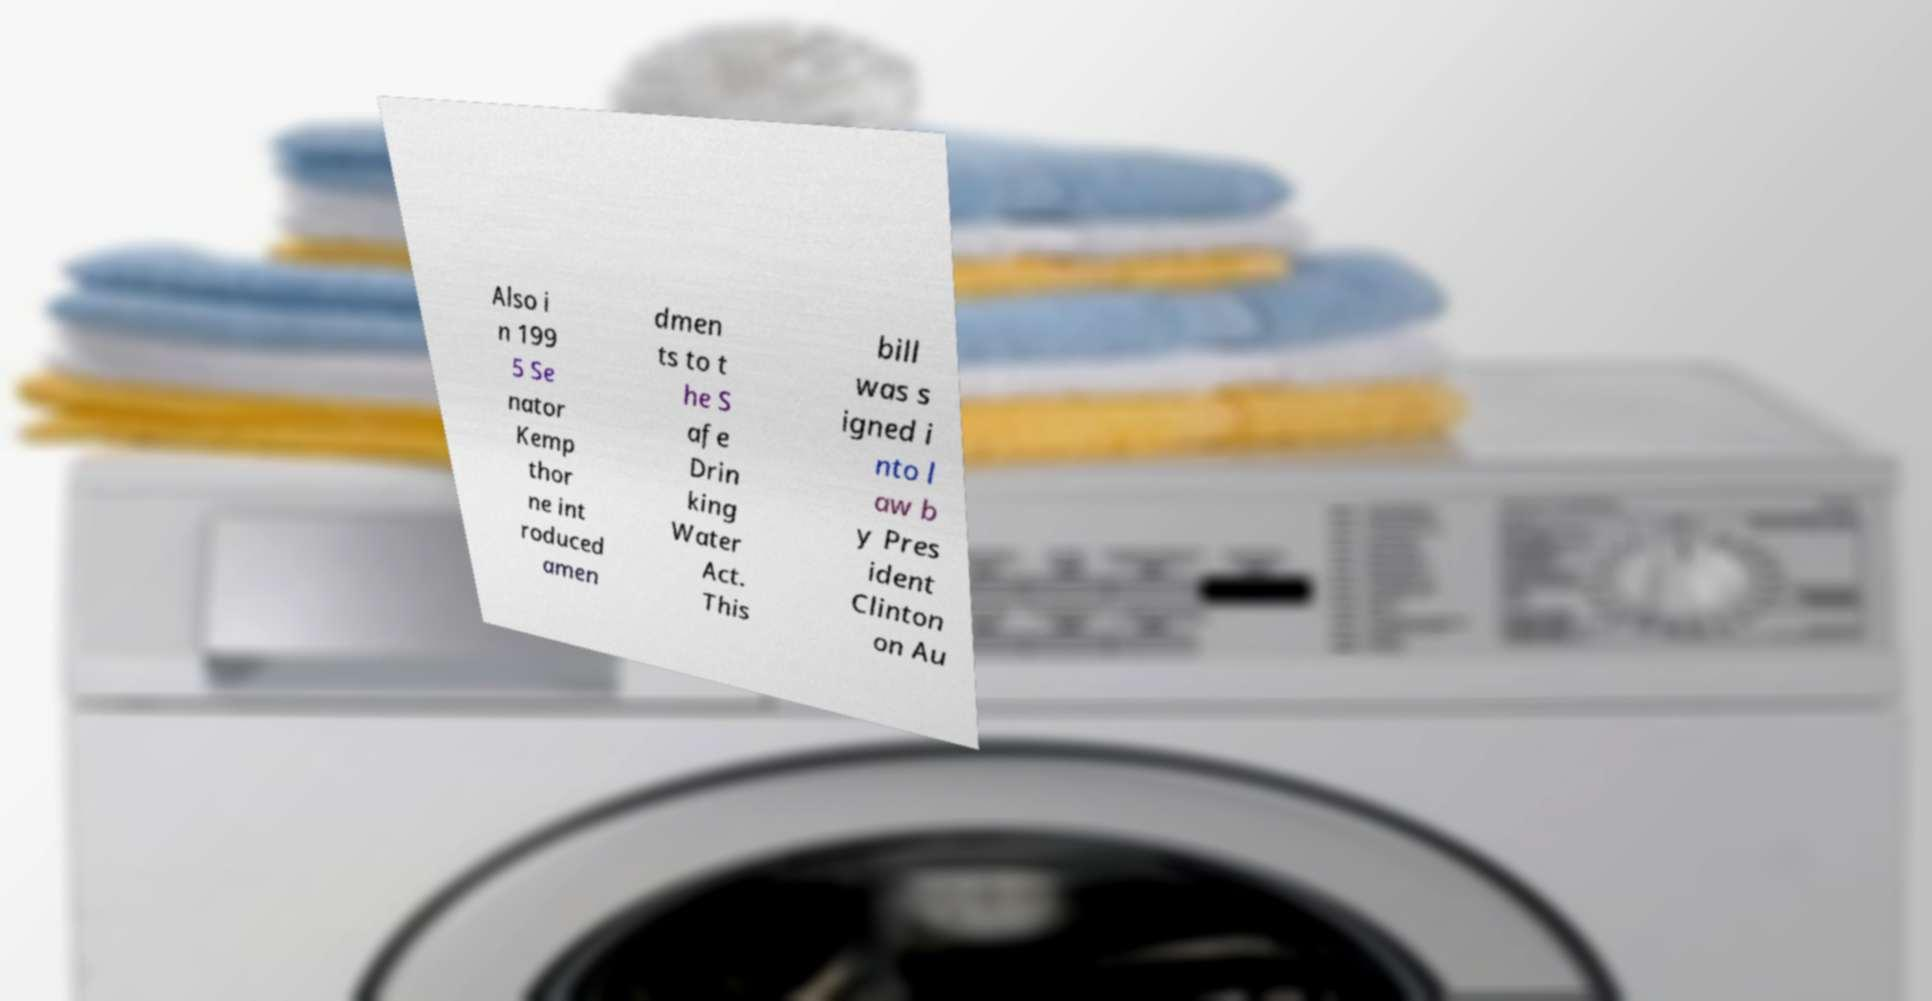Can you accurately transcribe the text from the provided image for me? Also i n 199 5 Se nator Kemp thor ne int roduced amen dmen ts to t he S afe Drin king Water Act. This bill was s igned i nto l aw b y Pres ident Clinton on Au 